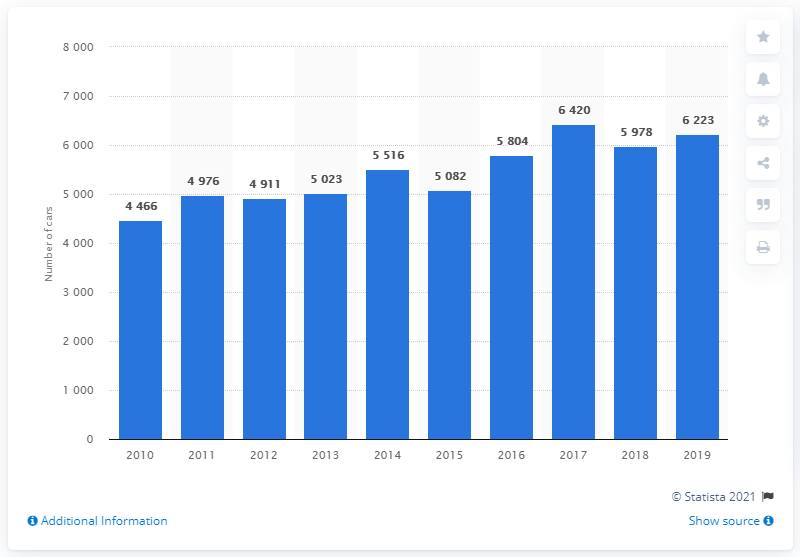Mention a couple of crucial points in this snapshot. In 2019, a total of 6,223 Mercedes-Benz cars were sold in Finland. 